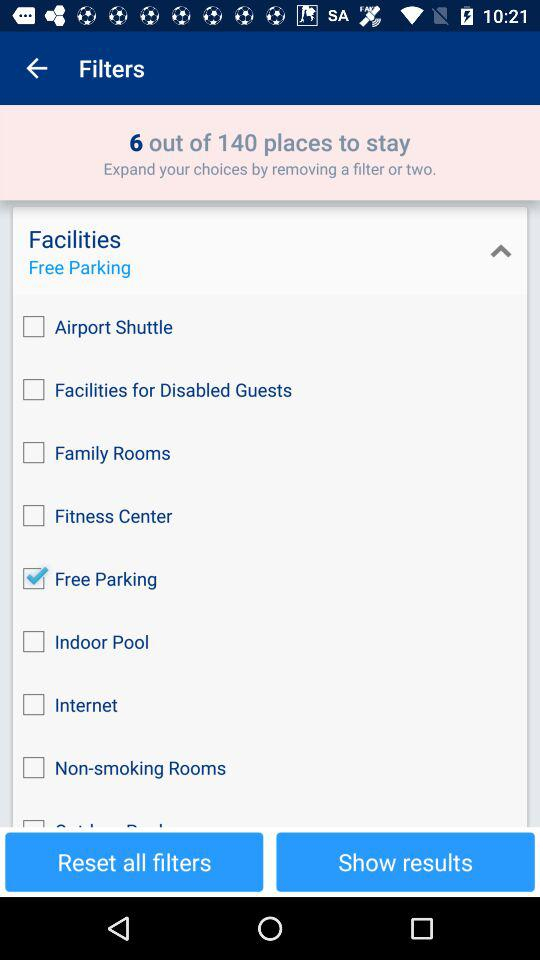How can choices be extended? The choices can be extended by removing a filter or two. 